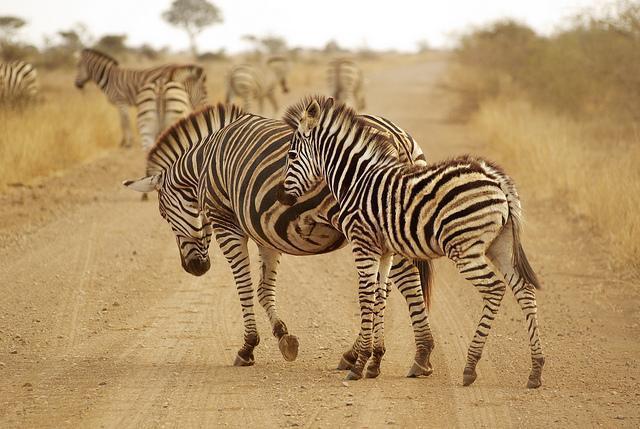How many animals can be seen?
Give a very brief answer. 7. How many zebras are there?
Give a very brief answer. 6. 